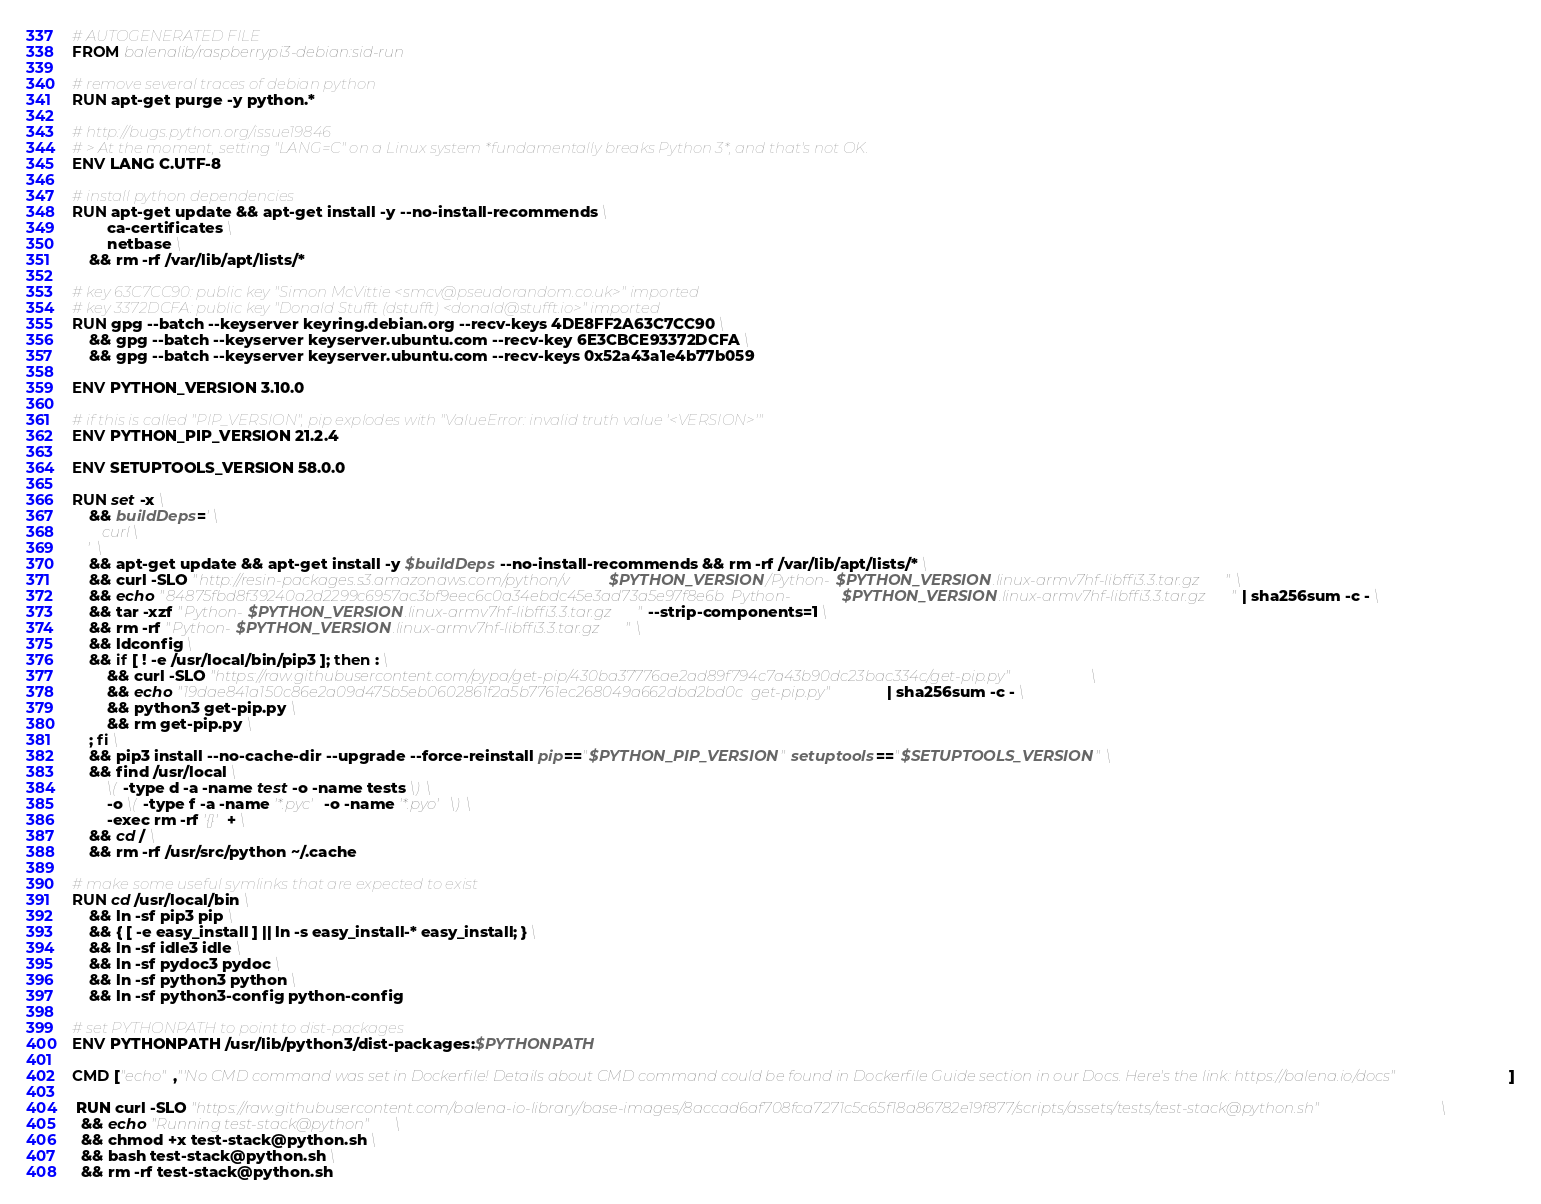Convert code to text. <code><loc_0><loc_0><loc_500><loc_500><_Dockerfile_># AUTOGENERATED FILE
FROM balenalib/raspberrypi3-debian:sid-run

# remove several traces of debian python
RUN apt-get purge -y python.*

# http://bugs.python.org/issue19846
# > At the moment, setting "LANG=C" on a Linux system *fundamentally breaks Python 3*, and that's not OK.
ENV LANG C.UTF-8

# install python dependencies
RUN apt-get update && apt-get install -y --no-install-recommends \
		ca-certificates \
		netbase \
	&& rm -rf /var/lib/apt/lists/*

# key 63C7CC90: public key "Simon McVittie <smcv@pseudorandom.co.uk>" imported
# key 3372DCFA: public key "Donald Stufft (dstufft) <donald@stufft.io>" imported
RUN gpg --batch --keyserver keyring.debian.org --recv-keys 4DE8FF2A63C7CC90 \
	&& gpg --batch --keyserver keyserver.ubuntu.com --recv-key 6E3CBCE93372DCFA \
	&& gpg --batch --keyserver keyserver.ubuntu.com --recv-keys 0x52a43a1e4b77b059

ENV PYTHON_VERSION 3.10.0

# if this is called "PIP_VERSION", pip explodes with "ValueError: invalid truth value '<VERSION>'"
ENV PYTHON_PIP_VERSION 21.2.4

ENV SETUPTOOLS_VERSION 58.0.0

RUN set -x \
	&& buildDeps=' \
		curl \
	' \
	&& apt-get update && apt-get install -y $buildDeps --no-install-recommends && rm -rf /var/lib/apt/lists/* \
	&& curl -SLO "http://resin-packages.s3.amazonaws.com/python/v$PYTHON_VERSION/Python-$PYTHON_VERSION.linux-armv7hf-libffi3.3.tar.gz" \
	&& echo "84875fbd8f39240a2d2299c6957ac3bf9eec6c0a34ebdc45e3ad73a5e97f8e6b  Python-$PYTHON_VERSION.linux-armv7hf-libffi3.3.tar.gz" | sha256sum -c - \
	&& tar -xzf "Python-$PYTHON_VERSION.linux-armv7hf-libffi3.3.tar.gz" --strip-components=1 \
	&& rm -rf "Python-$PYTHON_VERSION.linux-armv7hf-libffi3.3.tar.gz" \
	&& ldconfig \
	&& if [ ! -e /usr/local/bin/pip3 ]; then : \
		&& curl -SLO "https://raw.githubusercontent.com/pypa/get-pip/430ba37776ae2ad89f794c7a43b90dc23bac334c/get-pip.py" \
		&& echo "19dae841a150c86e2a09d475b5eb0602861f2a5b7761ec268049a662dbd2bd0c  get-pip.py" | sha256sum -c - \
		&& python3 get-pip.py \
		&& rm get-pip.py \
	; fi \
	&& pip3 install --no-cache-dir --upgrade --force-reinstall pip=="$PYTHON_PIP_VERSION" setuptools=="$SETUPTOOLS_VERSION" \
	&& find /usr/local \
		\( -type d -a -name test -o -name tests \) \
		-o \( -type f -a -name '*.pyc' -o -name '*.pyo' \) \
		-exec rm -rf '{}' + \
	&& cd / \
	&& rm -rf /usr/src/python ~/.cache

# make some useful symlinks that are expected to exist
RUN cd /usr/local/bin \
	&& ln -sf pip3 pip \
	&& { [ -e easy_install ] || ln -s easy_install-* easy_install; } \
	&& ln -sf idle3 idle \
	&& ln -sf pydoc3 pydoc \
	&& ln -sf python3 python \
	&& ln -sf python3-config python-config

# set PYTHONPATH to point to dist-packages
ENV PYTHONPATH /usr/lib/python3/dist-packages:$PYTHONPATH

CMD ["echo","'No CMD command was set in Dockerfile! Details about CMD command could be found in Dockerfile Guide section in our Docs. Here's the link: https://balena.io/docs"]

 RUN curl -SLO "https://raw.githubusercontent.com/balena-io-library/base-images/8accad6af708fca7271c5c65f18a86782e19f877/scripts/assets/tests/test-stack@python.sh" \
  && echo "Running test-stack@python" \
  && chmod +x test-stack@python.sh \
  && bash test-stack@python.sh \
  && rm -rf test-stack@python.sh 
</code> 